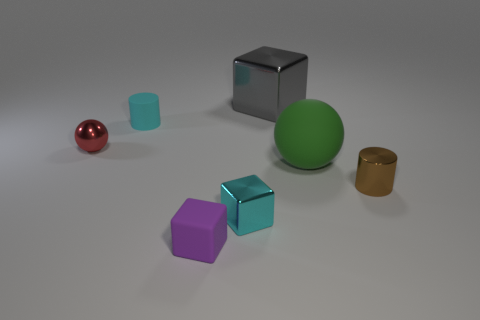Subtract all tiny cyan cubes. How many cubes are left? 2 Add 2 large green matte objects. How many objects exist? 9 Subtract all brown cylinders. How many cylinders are left? 1 Subtract all cubes. How many objects are left? 4 Subtract 2 cylinders. How many cylinders are left? 0 Subtract all gray cylinders. How many green spheres are left? 1 Subtract all large blue things. Subtract all small brown metallic cylinders. How many objects are left? 6 Add 2 shiny things. How many shiny things are left? 6 Add 5 green matte blocks. How many green matte blocks exist? 5 Subtract 0 purple balls. How many objects are left? 7 